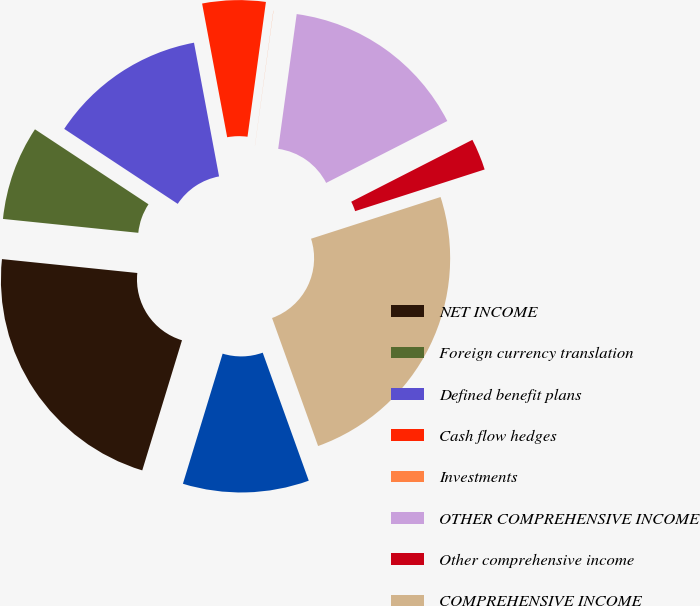Convert chart to OTSL. <chart><loc_0><loc_0><loc_500><loc_500><pie_chart><fcel>NET INCOME<fcel>Foreign currency translation<fcel>Defined benefit plans<fcel>Cash flow hedges<fcel>Investments<fcel>OTHER COMPREHENSIVE INCOME<fcel>Other comprehensive income<fcel>COMPREHENSIVE INCOME<fcel>Comprehensive income<nl><fcel>21.91%<fcel>7.66%<fcel>12.76%<fcel>5.11%<fcel>0.01%<fcel>15.31%<fcel>2.56%<fcel>24.46%<fcel>10.21%<nl></chart> 